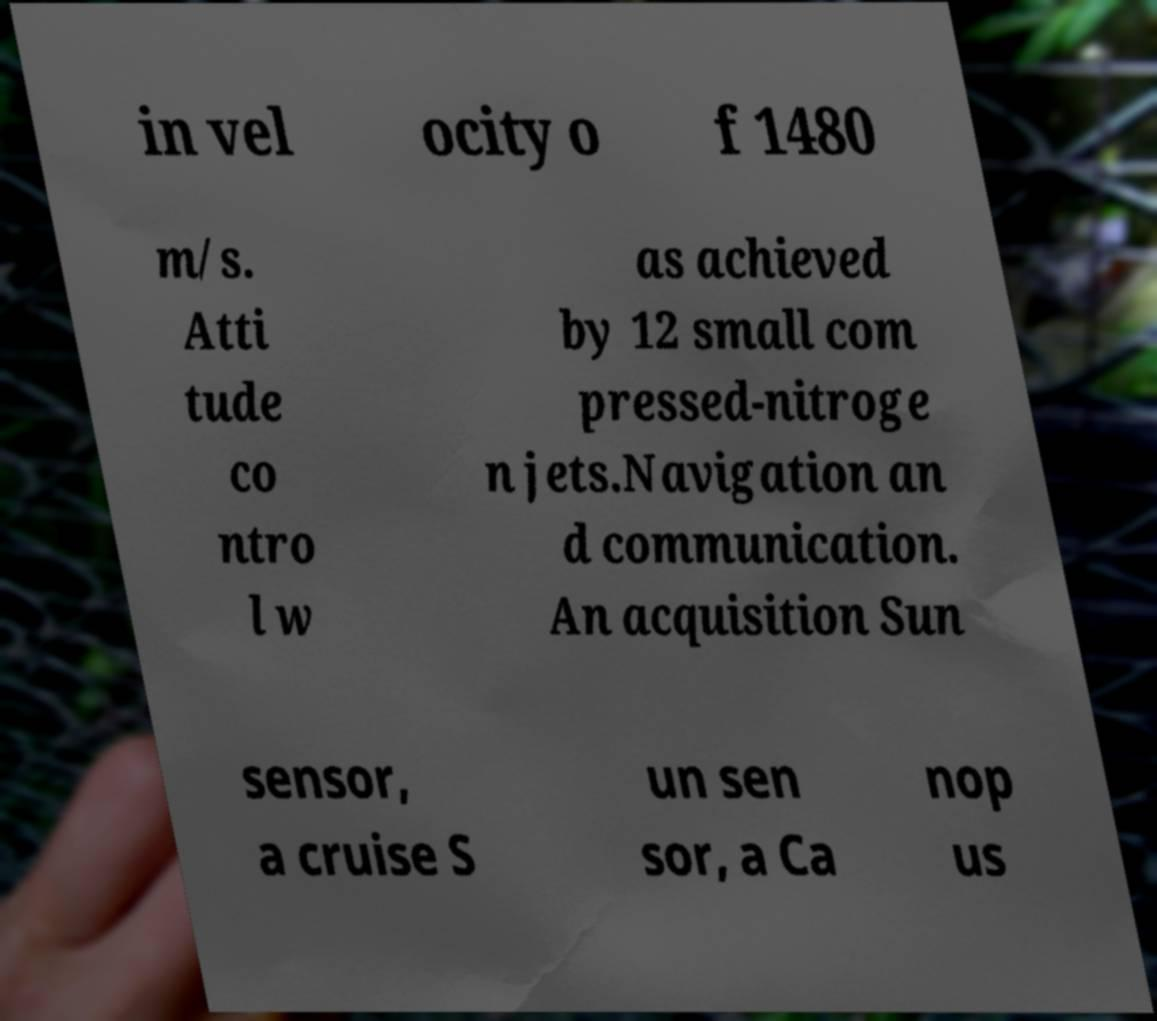Can you accurately transcribe the text from the provided image for me? in vel ocity o f 1480 m/s. Atti tude co ntro l w as achieved by 12 small com pressed-nitroge n jets.Navigation an d communication. An acquisition Sun sensor, a cruise S un sen sor, a Ca nop us 